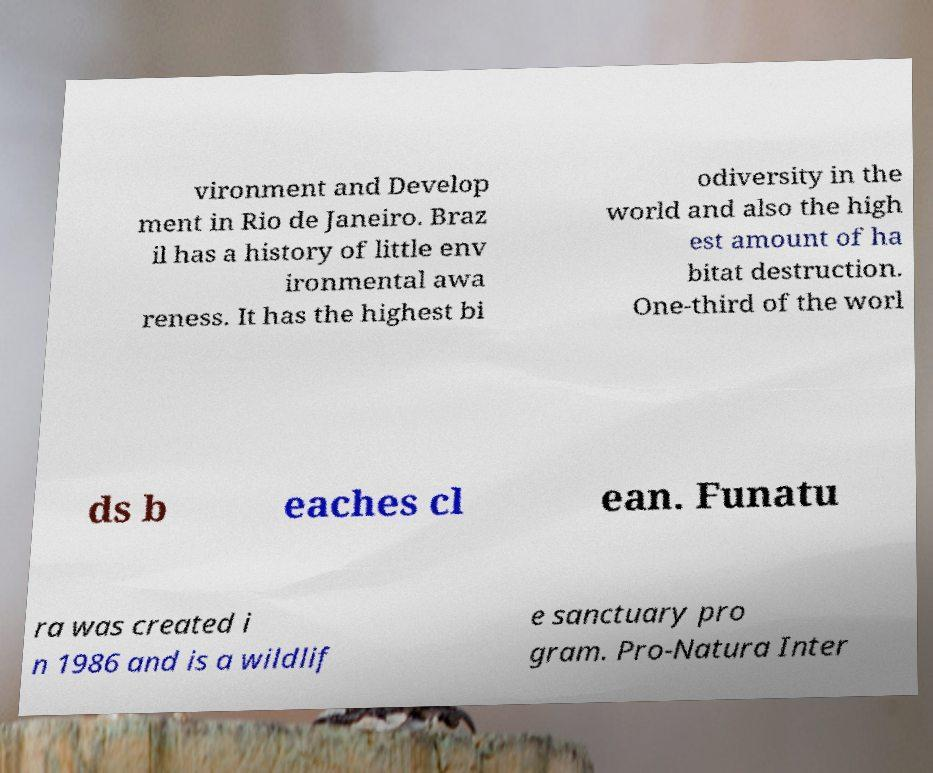Please identify and transcribe the text found in this image. vironment and Develop ment in Rio de Janeiro. Braz il has a history of little env ironmental awa reness. It has the highest bi odiversity in the world and also the high est amount of ha bitat destruction. One-third of the worl ds b eaches cl ean. Funatu ra was created i n 1986 and is a wildlif e sanctuary pro gram. Pro-Natura Inter 